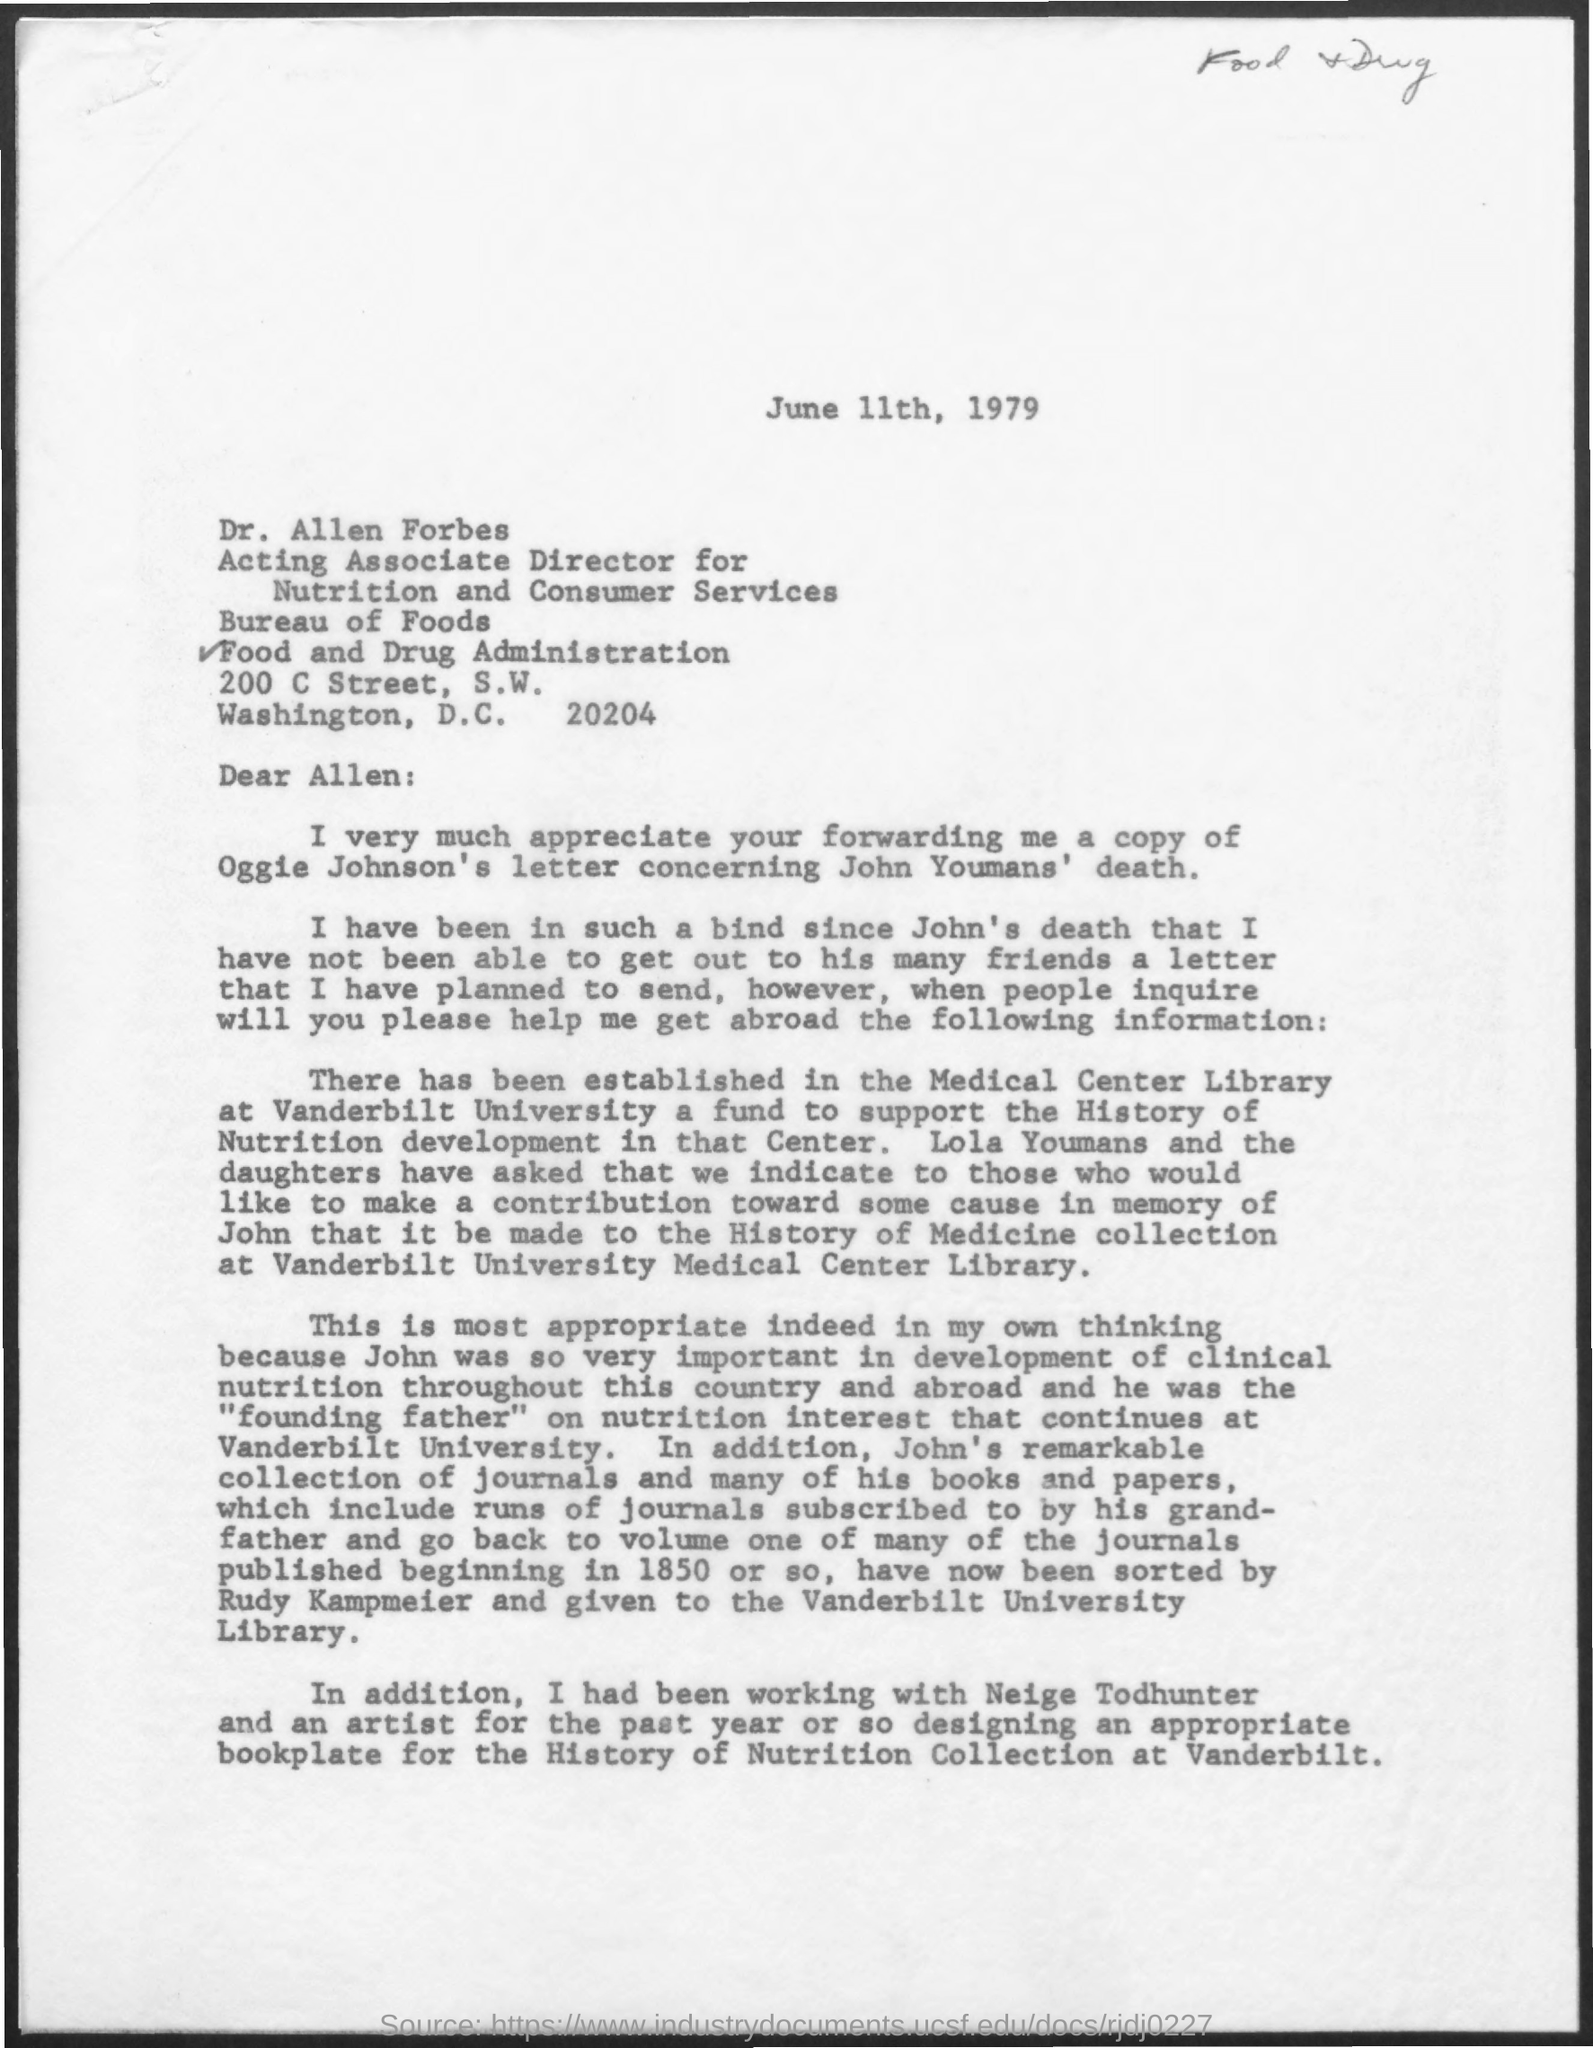What is the issued date of this letter?
Provide a short and direct response. June 11th, 1979. 